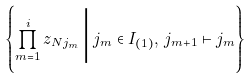<formula> <loc_0><loc_0><loc_500><loc_500>\left \{ \prod _ { m = 1 } ^ { i } z _ { N j _ { m } } \, \Big | \, j _ { m } \in I _ { ( 1 ) } , \, j _ { m + 1 } \vdash j _ { m } \right \}</formula> 